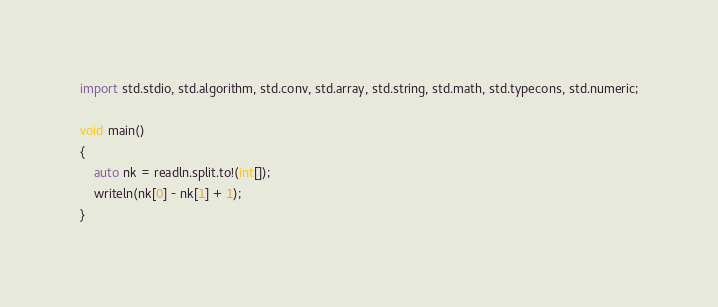<code> <loc_0><loc_0><loc_500><loc_500><_D_>import std.stdio, std.algorithm, std.conv, std.array, std.string, std.math, std.typecons, std.numeric;

void main()
{
    auto nk = readln.split.to!(int[]);
    writeln(nk[0] - nk[1] + 1);
}</code> 